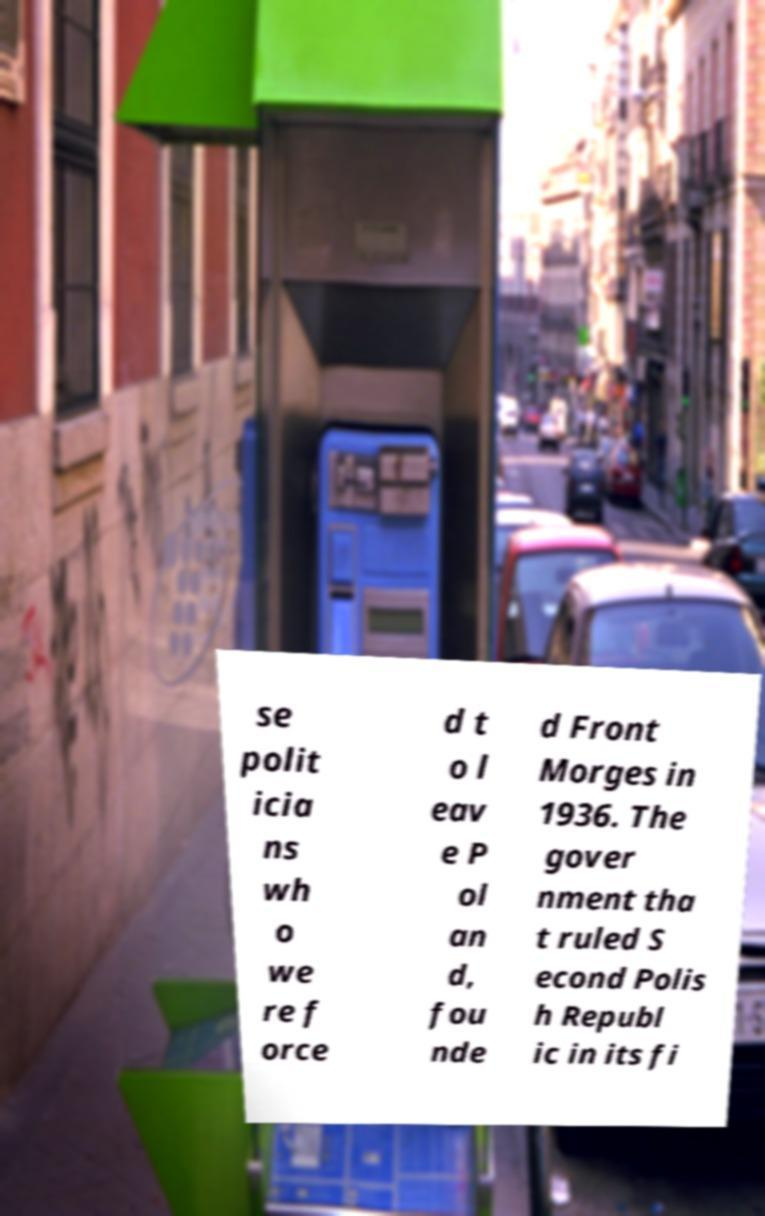I need the written content from this picture converted into text. Can you do that? se polit icia ns wh o we re f orce d t o l eav e P ol an d, fou nde d Front Morges in 1936. The gover nment tha t ruled S econd Polis h Republ ic in its fi 